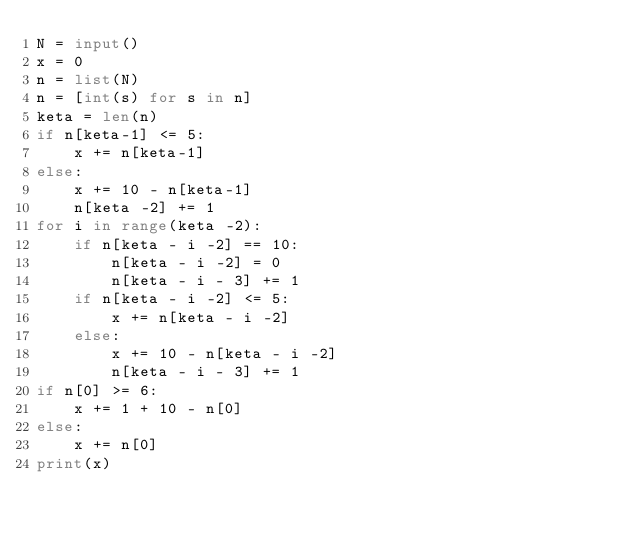<code> <loc_0><loc_0><loc_500><loc_500><_Python_>N = input()
x = 0
n = list(N)
n = [int(s) for s in n]
keta = len(n)
if n[keta-1] <= 5:
    x += n[keta-1]
else:
    x += 10 - n[keta-1]
    n[keta -2] += 1
for i in range(keta -2):
    if n[keta - i -2] == 10:
        n[keta - i -2] = 0
        n[keta - i - 3] += 1
    if n[keta - i -2] <= 5:
        x += n[keta - i -2]
    else:
        x += 10 - n[keta - i -2]
        n[keta - i - 3] += 1
if n[0] >= 6:
    x += 1 + 10 - n[0]
else:
    x += n[0]
print(x)</code> 